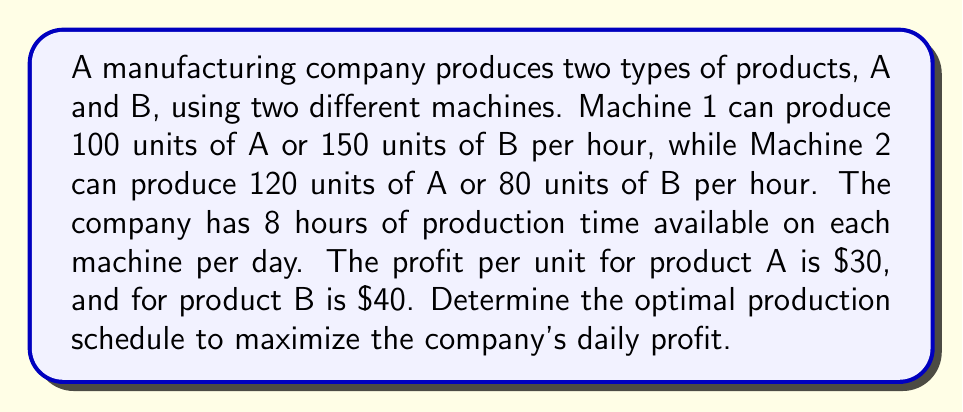Help me with this question. To solve this optimization problem, we'll use linear programming. Let's define our variables:

$x$: Number of units of product A to produce
$y$: Number of units of product B to produce

Step 1: Formulate the objective function
We want to maximize profit:
$$ \text{Maximize } Z = 30x + 40y $$

Step 2: Identify constraints
1. Machine 1 time constraint: $\frac{x}{100} + \frac{y}{150} \leq 8$
2. Machine 2 time constraint: $\frac{x}{120} + \frac{y}{80} \leq 8$
3. Non-negativity constraints: $x \geq 0, y \geq 0$

Step 3: Simplify constraints
1. $3x + 2y \leq 2400$
2. $2x + 3y \leq 1920$

Step 4: Graph the constraints and identify the feasible region

[asy]
size(200);
import graph;

real f1(real x) {return (2400-3x)/2;}
real f2(real x) {return (1920-2x)/3;}

draw(graph(f1,0,800),blue);
draw(graph(f2,0,960),red);
draw((0,0)--(800,0)--(800,800)--(0,800)--cycle);

label("3x + 2y = 2400",(-20,1200),blue);
label("2x + 3y = 1920",(1000,620),red);

fill((0,0)--(800,0)--(640,426.67)--(480,640)--(0,800)--cycle,gray(0.8));

dot((480,640));
label("(480, 640)",(480,640),NE);

xaxis("x",arrow=Arrow);
yaxis("y",arrow=Arrow);
[/asy]

Step 5: Identify corner points of the feasible region
(0, 0), (800, 0), (640, 426.67), (480, 640), (0, 800)

Step 6: Evaluate the objective function at each corner point
$Z(0, 0) = 0$
$Z(800, 0) = 24,000$
$Z(640, 426.67) = 36,266.80$
$Z(480, 640) = 40,000$
$Z(0, 800) = 32,000$

The maximum profit occurs at the point (480, 640).
Answer: The optimal production schedule is to produce 480 units of product A and 640 units of product B daily, resulting in a maximum profit of $40,000 per day. 